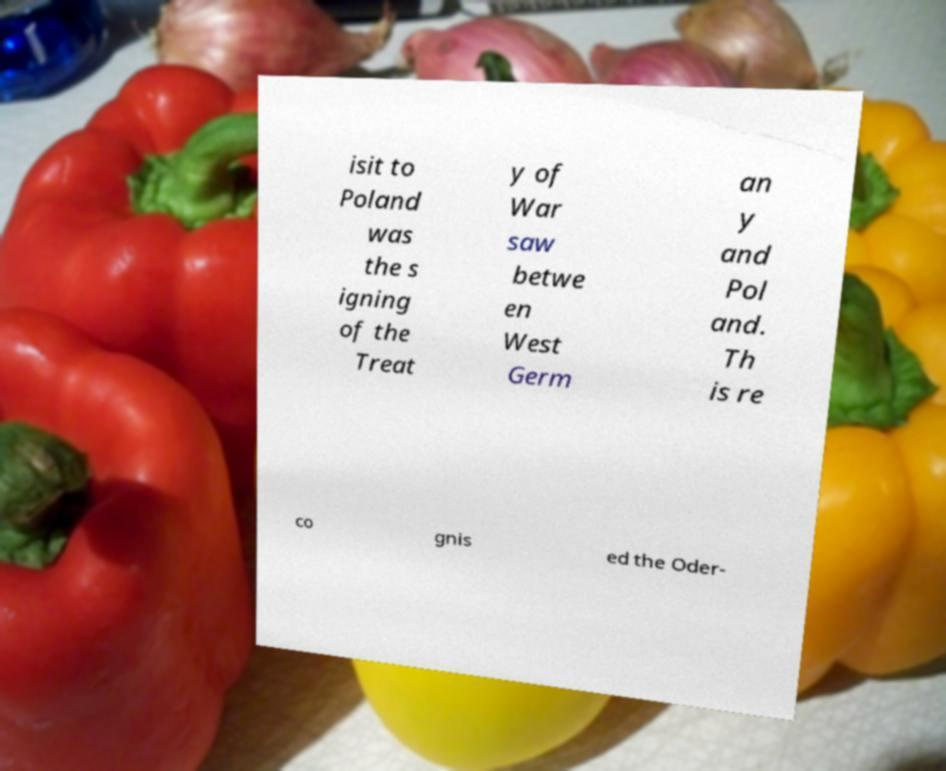Could you assist in decoding the text presented in this image and type it out clearly? isit to Poland was the s igning of the Treat y of War saw betwe en West Germ an y and Pol and. Th is re co gnis ed the Oder- 